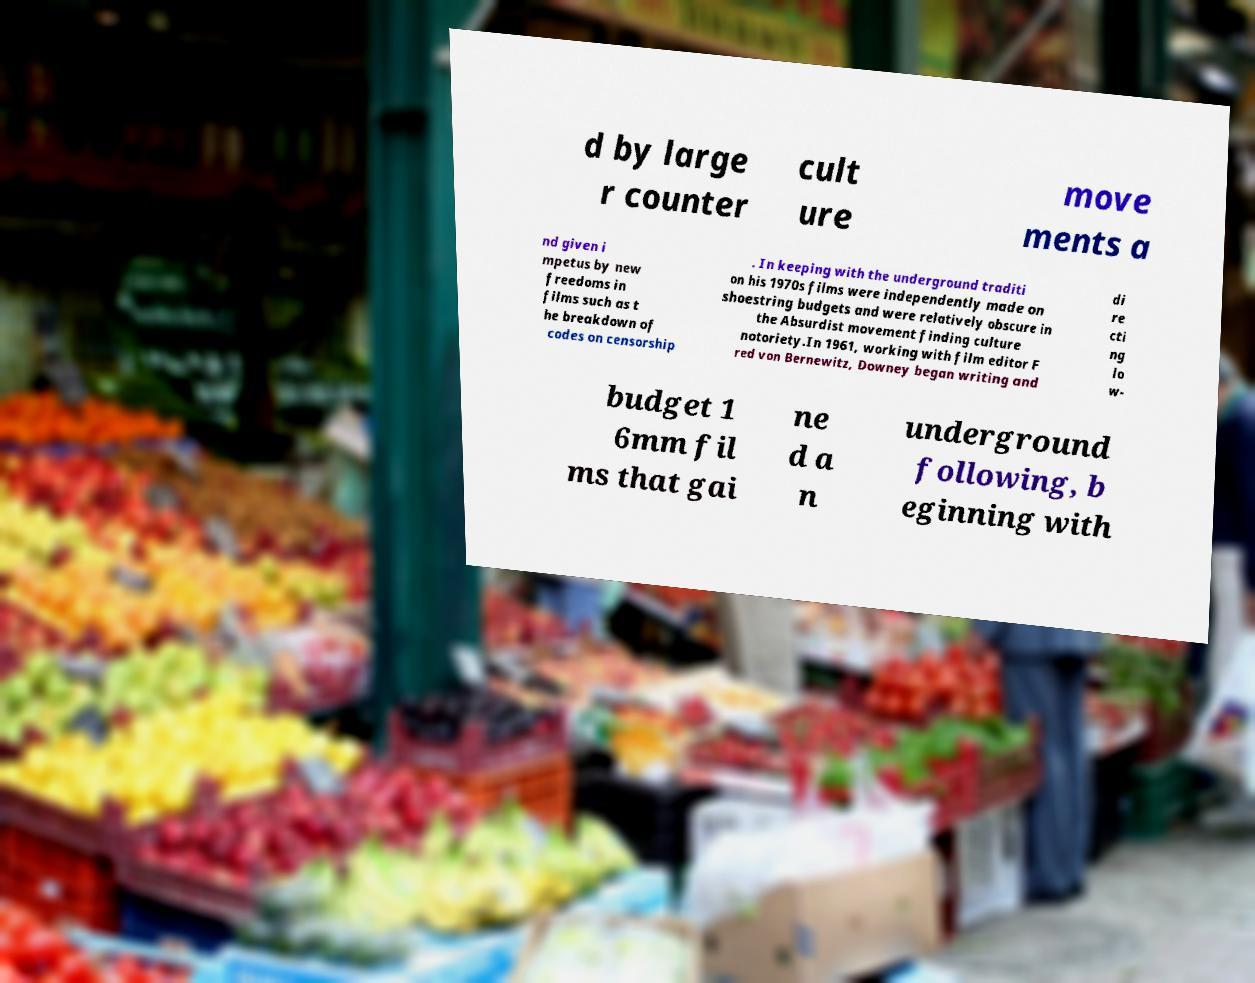Please read and relay the text visible in this image. What does it say? d by large r counter cult ure move ments a nd given i mpetus by new freedoms in films such as t he breakdown of codes on censorship . In keeping with the underground traditi on his 1970s films were independently made on shoestring budgets and were relatively obscure in the Absurdist movement finding culture notoriety.In 1961, working with film editor F red von Bernewitz, Downey began writing and di re cti ng lo w- budget 1 6mm fil ms that gai ne d a n underground following, b eginning with 